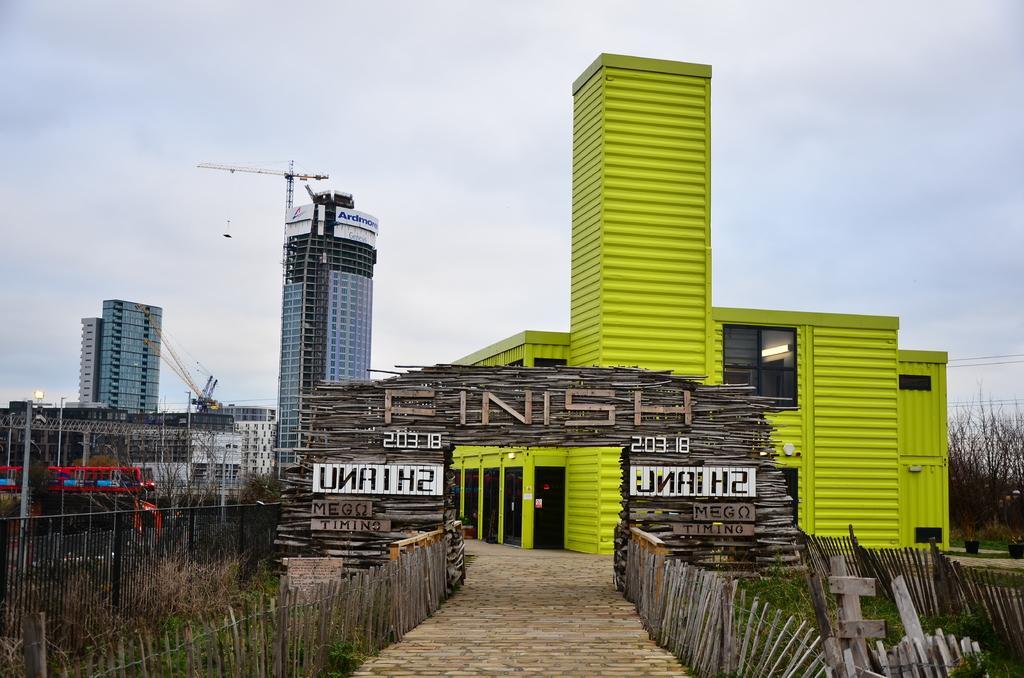Can you describe this image briefly? In the picture we can see the entrance with wooden poles and behind it, we can see the building with glass window and beside it, we can see the tower building with many floors and in the background we can see the sky. 